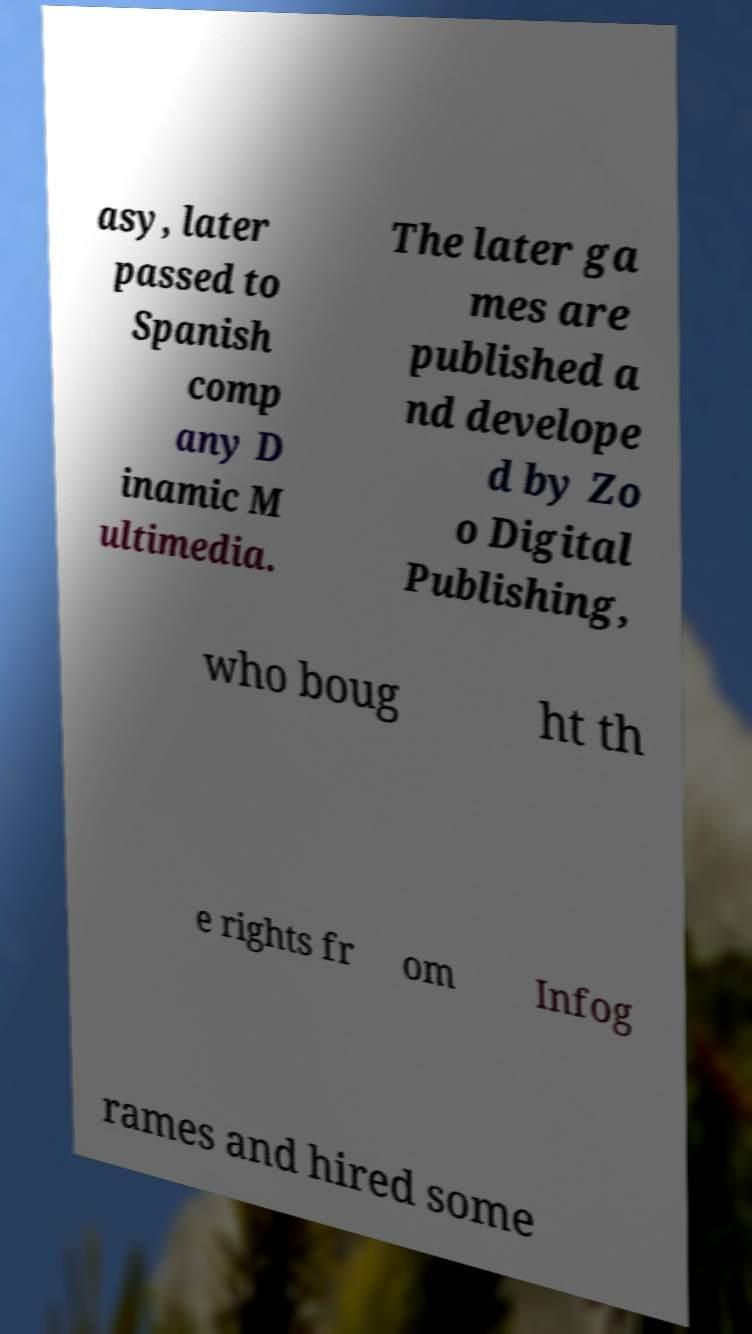Please read and relay the text visible in this image. What does it say? asy, later passed to Spanish comp any D inamic M ultimedia. The later ga mes are published a nd develope d by Zo o Digital Publishing, who boug ht th e rights fr om Infog rames and hired some 